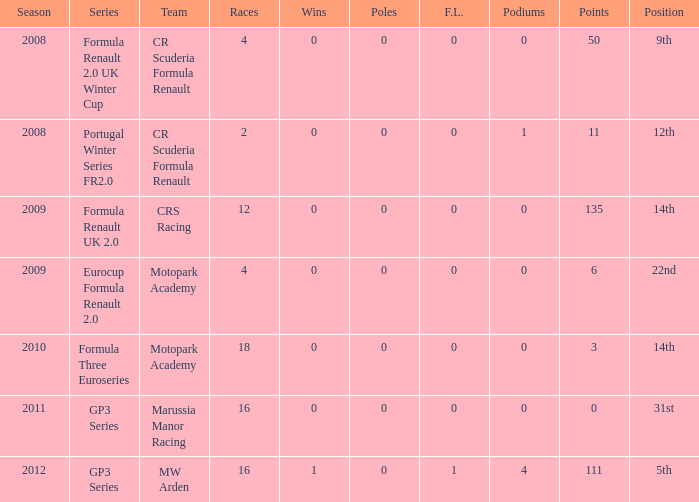What is the highest number of poles mentioned? 0.0. 